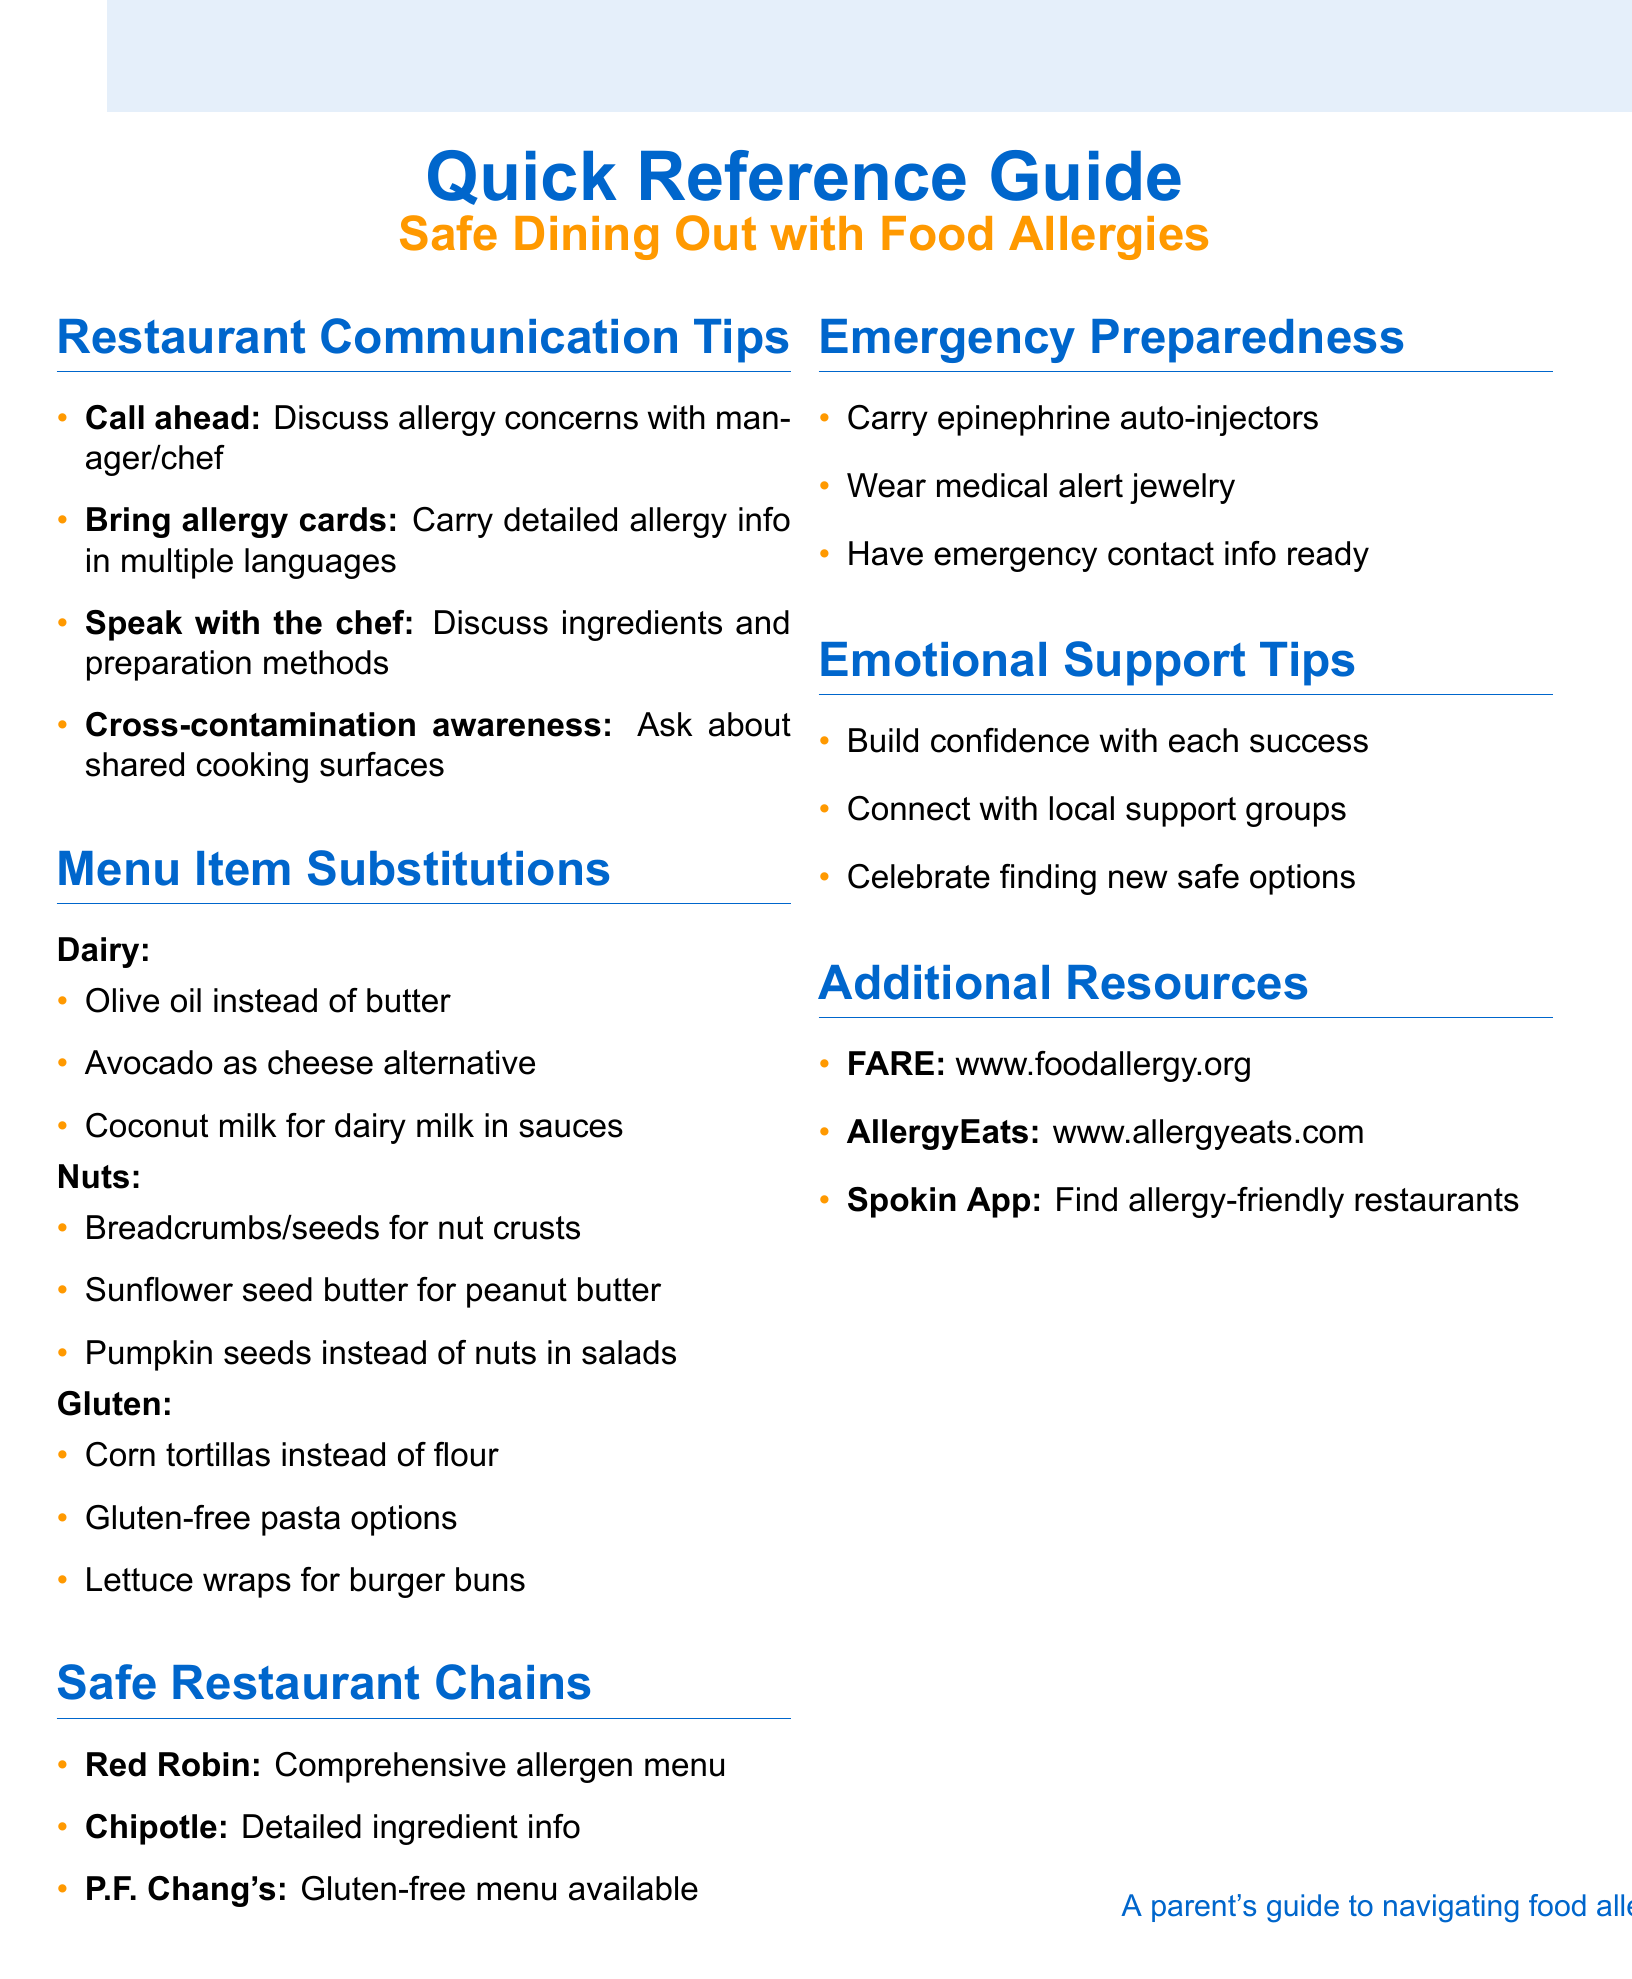What is the title of the guide? The title is the first key detail mentioned in the document, establishing the purpose of the guide.
Answer: Quick Reference Guide for Safe Dining Out with Food Allergies How many restaurant communication tips are listed? The total number of tips provides insight into the communication strategies shared in the guide.
Answer: 4 Which restaurant is mentioned as offering a comprehensive allergen menu? This question pinpoints a safe dining option highlighted in the guide for families with food allergies.
Answer: Red Robin What is a substitution for dairy in cooking? This inquiries specifically into the suggested alternatives for certain allergens provided in the document.
Answer: Olive oil instead of butter What should you carry for emergency preparedness? This question focuses on the critical items mentioned for ensuring safety during dining out.
Answer: Epinephrine auto-injectors Which mobile app is recommended for finding allergy-friendly restaurants? This seeks a specific resource provided in the guide that parents can use to aid their dining experiences.
Answer: Spokin App What is one emotional support tip mentioned? This question aims to uncover the advice for coping with the emotional aspects of dealing with food allergies.
Answer: Celebrate small victories in finding new safe dining options What is the name of the organization represented by the abbreviation FARE? This requires recalling an organization mentioned for additional support and resources.
Answer: Food Allergy Research & Education 